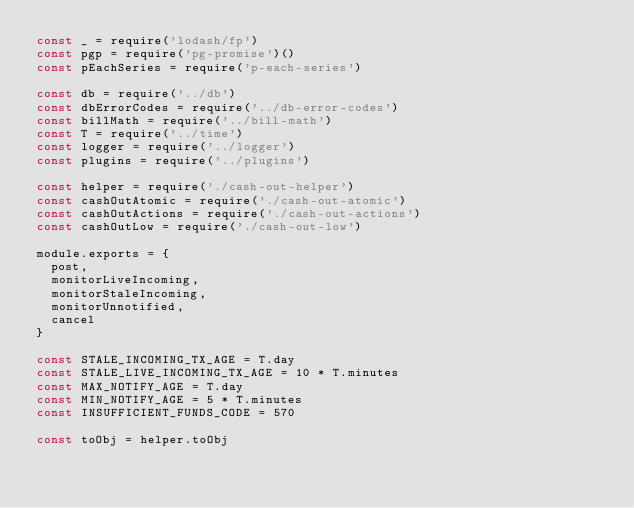<code> <loc_0><loc_0><loc_500><loc_500><_JavaScript_>const _ = require('lodash/fp')
const pgp = require('pg-promise')()
const pEachSeries = require('p-each-series')

const db = require('../db')
const dbErrorCodes = require('../db-error-codes')
const billMath = require('../bill-math')
const T = require('../time')
const logger = require('../logger')
const plugins = require('../plugins')

const helper = require('./cash-out-helper')
const cashOutAtomic = require('./cash-out-atomic')
const cashOutActions = require('./cash-out-actions')
const cashOutLow = require('./cash-out-low')

module.exports = {
  post,
  monitorLiveIncoming,
  monitorStaleIncoming,
  monitorUnnotified,
  cancel
}

const STALE_INCOMING_TX_AGE = T.day
const STALE_LIVE_INCOMING_TX_AGE = 10 * T.minutes
const MAX_NOTIFY_AGE = T.day
const MIN_NOTIFY_AGE = 5 * T.minutes
const INSUFFICIENT_FUNDS_CODE = 570

const toObj = helper.toObj
</code> 